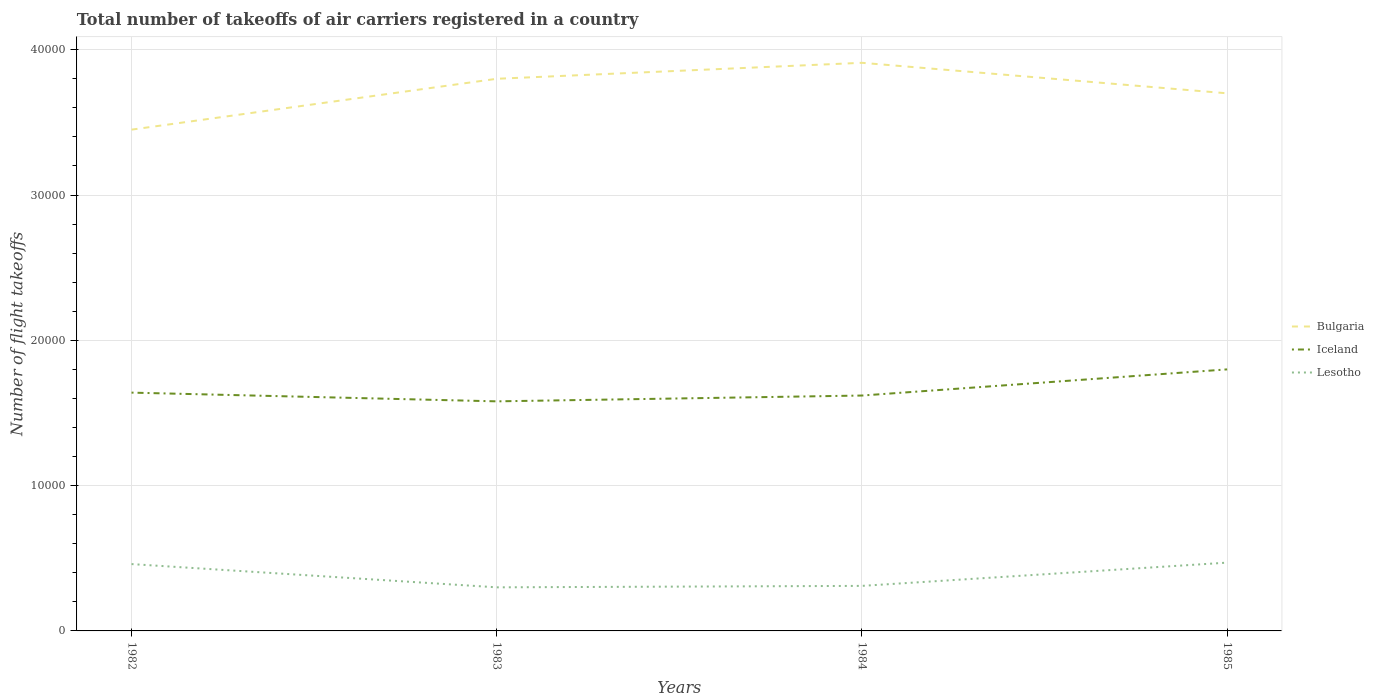Does the line corresponding to Lesotho intersect with the line corresponding to Bulgaria?
Your response must be concise. No. Across all years, what is the maximum total number of flight takeoffs in Bulgaria?
Your answer should be compact. 3.45e+04. In which year was the total number of flight takeoffs in Bulgaria maximum?
Make the answer very short. 1982. What is the total total number of flight takeoffs in Bulgaria in the graph?
Give a very brief answer. -3500. What is the difference between the highest and the second highest total number of flight takeoffs in Iceland?
Your answer should be very brief. 2200. Is the total number of flight takeoffs in Bulgaria strictly greater than the total number of flight takeoffs in Iceland over the years?
Provide a succinct answer. No. How many years are there in the graph?
Give a very brief answer. 4. What is the difference between two consecutive major ticks on the Y-axis?
Provide a short and direct response. 10000. Are the values on the major ticks of Y-axis written in scientific E-notation?
Your answer should be very brief. No. How many legend labels are there?
Provide a short and direct response. 3. What is the title of the graph?
Offer a terse response. Total number of takeoffs of air carriers registered in a country. Does "Montenegro" appear as one of the legend labels in the graph?
Your response must be concise. No. What is the label or title of the Y-axis?
Ensure brevity in your answer.  Number of flight takeoffs. What is the Number of flight takeoffs of Bulgaria in 1982?
Provide a succinct answer. 3.45e+04. What is the Number of flight takeoffs in Iceland in 1982?
Make the answer very short. 1.64e+04. What is the Number of flight takeoffs of Lesotho in 1982?
Provide a short and direct response. 4600. What is the Number of flight takeoffs of Bulgaria in 1983?
Your answer should be compact. 3.80e+04. What is the Number of flight takeoffs in Iceland in 1983?
Offer a very short reply. 1.58e+04. What is the Number of flight takeoffs in Lesotho in 1983?
Your answer should be very brief. 3000. What is the Number of flight takeoffs in Bulgaria in 1984?
Keep it short and to the point. 3.91e+04. What is the Number of flight takeoffs in Iceland in 1984?
Provide a succinct answer. 1.62e+04. What is the Number of flight takeoffs of Lesotho in 1984?
Keep it short and to the point. 3100. What is the Number of flight takeoffs in Bulgaria in 1985?
Give a very brief answer. 3.70e+04. What is the Number of flight takeoffs of Iceland in 1985?
Your response must be concise. 1.80e+04. What is the Number of flight takeoffs of Lesotho in 1985?
Make the answer very short. 4700. Across all years, what is the maximum Number of flight takeoffs of Bulgaria?
Offer a very short reply. 3.91e+04. Across all years, what is the maximum Number of flight takeoffs in Iceland?
Ensure brevity in your answer.  1.80e+04. Across all years, what is the maximum Number of flight takeoffs of Lesotho?
Offer a very short reply. 4700. Across all years, what is the minimum Number of flight takeoffs in Bulgaria?
Provide a short and direct response. 3.45e+04. Across all years, what is the minimum Number of flight takeoffs in Iceland?
Offer a terse response. 1.58e+04. Across all years, what is the minimum Number of flight takeoffs in Lesotho?
Offer a very short reply. 3000. What is the total Number of flight takeoffs in Bulgaria in the graph?
Your response must be concise. 1.49e+05. What is the total Number of flight takeoffs of Iceland in the graph?
Offer a very short reply. 6.64e+04. What is the total Number of flight takeoffs in Lesotho in the graph?
Provide a succinct answer. 1.54e+04. What is the difference between the Number of flight takeoffs in Bulgaria in 1982 and that in 1983?
Your answer should be compact. -3500. What is the difference between the Number of flight takeoffs in Iceland in 1982 and that in 1983?
Ensure brevity in your answer.  600. What is the difference between the Number of flight takeoffs in Lesotho in 1982 and that in 1983?
Your response must be concise. 1600. What is the difference between the Number of flight takeoffs of Bulgaria in 1982 and that in 1984?
Provide a succinct answer. -4600. What is the difference between the Number of flight takeoffs in Lesotho in 1982 and that in 1984?
Your answer should be compact. 1500. What is the difference between the Number of flight takeoffs in Bulgaria in 1982 and that in 1985?
Your response must be concise. -2500. What is the difference between the Number of flight takeoffs of Iceland in 1982 and that in 1985?
Your answer should be compact. -1600. What is the difference between the Number of flight takeoffs of Lesotho in 1982 and that in 1985?
Offer a very short reply. -100. What is the difference between the Number of flight takeoffs of Bulgaria in 1983 and that in 1984?
Offer a very short reply. -1100. What is the difference between the Number of flight takeoffs in Iceland in 1983 and that in 1984?
Your response must be concise. -400. What is the difference between the Number of flight takeoffs in Lesotho in 1983 and that in 1984?
Offer a terse response. -100. What is the difference between the Number of flight takeoffs in Bulgaria in 1983 and that in 1985?
Keep it short and to the point. 1000. What is the difference between the Number of flight takeoffs of Iceland in 1983 and that in 1985?
Offer a terse response. -2200. What is the difference between the Number of flight takeoffs of Lesotho in 1983 and that in 1985?
Provide a succinct answer. -1700. What is the difference between the Number of flight takeoffs in Bulgaria in 1984 and that in 1985?
Ensure brevity in your answer.  2100. What is the difference between the Number of flight takeoffs of Iceland in 1984 and that in 1985?
Offer a very short reply. -1800. What is the difference between the Number of flight takeoffs in Lesotho in 1984 and that in 1985?
Give a very brief answer. -1600. What is the difference between the Number of flight takeoffs in Bulgaria in 1982 and the Number of flight takeoffs in Iceland in 1983?
Your response must be concise. 1.87e+04. What is the difference between the Number of flight takeoffs in Bulgaria in 1982 and the Number of flight takeoffs in Lesotho in 1983?
Your answer should be compact. 3.15e+04. What is the difference between the Number of flight takeoffs of Iceland in 1982 and the Number of flight takeoffs of Lesotho in 1983?
Offer a terse response. 1.34e+04. What is the difference between the Number of flight takeoffs in Bulgaria in 1982 and the Number of flight takeoffs in Iceland in 1984?
Ensure brevity in your answer.  1.83e+04. What is the difference between the Number of flight takeoffs in Bulgaria in 1982 and the Number of flight takeoffs in Lesotho in 1984?
Make the answer very short. 3.14e+04. What is the difference between the Number of flight takeoffs in Iceland in 1982 and the Number of flight takeoffs in Lesotho in 1984?
Give a very brief answer. 1.33e+04. What is the difference between the Number of flight takeoffs of Bulgaria in 1982 and the Number of flight takeoffs of Iceland in 1985?
Provide a short and direct response. 1.65e+04. What is the difference between the Number of flight takeoffs in Bulgaria in 1982 and the Number of flight takeoffs in Lesotho in 1985?
Offer a very short reply. 2.98e+04. What is the difference between the Number of flight takeoffs of Iceland in 1982 and the Number of flight takeoffs of Lesotho in 1985?
Your answer should be compact. 1.17e+04. What is the difference between the Number of flight takeoffs of Bulgaria in 1983 and the Number of flight takeoffs of Iceland in 1984?
Make the answer very short. 2.18e+04. What is the difference between the Number of flight takeoffs of Bulgaria in 1983 and the Number of flight takeoffs of Lesotho in 1984?
Make the answer very short. 3.49e+04. What is the difference between the Number of flight takeoffs of Iceland in 1983 and the Number of flight takeoffs of Lesotho in 1984?
Your response must be concise. 1.27e+04. What is the difference between the Number of flight takeoffs in Bulgaria in 1983 and the Number of flight takeoffs in Lesotho in 1985?
Provide a succinct answer. 3.33e+04. What is the difference between the Number of flight takeoffs of Iceland in 1983 and the Number of flight takeoffs of Lesotho in 1985?
Offer a terse response. 1.11e+04. What is the difference between the Number of flight takeoffs of Bulgaria in 1984 and the Number of flight takeoffs of Iceland in 1985?
Make the answer very short. 2.11e+04. What is the difference between the Number of flight takeoffs of Bulgaria in 1984 and the Number of flight takeoffs of Lesotho in 1985?
Ensure brevity in your answer.  3.44e+04. What is the difference between the Number of flight takeoffs in Iceland in 1984 and the Number of flight takeoffs in Lesotho in 1985?
Your answer should be very brief. 1.15e+04. What is the average Number of flight takeoffs of Bulgaria per year?
Provide a short and direct response. 3.72e+04. What is the average Number of flight takeoffs in Iceland per year?
Your answer should be very brief. 1.66e+04. What is the average Number of flight takeoffs of Lesotho per year?
Make the answer very short. 3850. In the year 1982, what is the difference between the Number of flight takeoffs in Bulgaria and Number of flight takeoffs in Iceland?
Provide a short and direct response. 1.81e+04. In the year 1982, what is the difference between the Number of flight takeoffs of Bulgaria and Number of flight takeoffs of Lesotho?
Offer a terse response. 2.99e+04. In the year 1982, what is the difference between the Number of flight takeoffs in Iceland and Number of flight takeoffs in Lesotho?
Your answer should be compact. 1.18e+04. In the year 1983, what is the difference between the Number of flight takeoffs in Bulgaria and Number of flight takeoffs in Iceland?
Provide a succinct answer. 2.22e+04. In the year 1983, what is the difference between the Number of flight takeoffs of Bulgaria and Number of flight takeoffs of Lesotho?
Give a very brief answer. 3.50e+04. In the year 1983, what is the difference between the Number of flight takeoffs of Iceland and Number of flight takeoffs of Lesotho?
Keep it short and to the point. 1.28e+04. In the year 1984, what is the difference between the Number of flight takeoffs of Bulgaria and Number of flight takeoffs of Iceland?
Your response must be concise. 2.29e+04. In the year 1984, what is the difference between the Number of flight takeoffs in Bulgaria and Number of flight takeoffs in Lesotho?
Your response must be concise. 3.60e+04. In the year 1984, what is the difference between the Number of flight takeoffs in Iceland and Number of flight takeoffs in Lesotho?
Provide a succinct answer. 1.31e+04. In the year 1985, what is the difference between the Number of flight takeoffs of Bulgaria and Number of flight takeoffs of Iceland?
Your answer should be very brief. 1.90e+04. In the year 1985, what is the difference between the Number of flight takeoffs of Bulgaria and Number of flight takeoffs of Lesotho?
Your response must be concise. 3.23e+04. In the year 1985, what is the difference between the Number of flight takeoffs in Iceland and Number of flight takeoffs in Lesotho?
Your response must be concise. 1.33e+04. What is the ratio of the Number of flight takeoffs in Bulgaria in 1982 to that in 1983?
Ensure brevity in your answer.  0.91. What is the ratio of the Number of flight takeoffs in Iceland in 1982 to that in 1983?
Your answer should be compact. 1.04. What is the ratio of the Number of flight takeoffs in Lesotho in 1982 to that in 1983?
Make the answer very short. 1.53. What is the ratio of the Number of flight takeoffs in Bulgaria in 1982 to that in 1984?
Your response must be concise. 0.88. What is the ratio of the Number of flight takeoffs of Iceland in 1982 to that in 1984?
Your answer should be compact. 1.01. What is the ratio of the Number of flight takeoffs in Lesotho in 1982 to that in 1984?
Your answer should be very brief. 1.48. What is the ratio of the Number of flight takeoffs in Bulgaria in 1982 to that in 1985?
Give a very brief answer. 0.93. What is the ratio of the Number of flight takeoffs in Iceland in 1982 to that in 1985?
Your answer should be compact. 0.91. What is the ratio of the Number of flight takeoffs of Lesotho in 1982 to that in 1985?
Make the answer very short. 0.98. What is the ratio of the Number of flight takeoffs of Bulgaria in 1983 to that in 1984?
Your answer should be very brief. 0.97. What is the ratio of the Number of flight takeoffs of Iceland in 1983 to that in 1984?
Keep it short and to the point. 0.98. What is the ratio of the Number of flight takeoffs of Lesotho in 1983 to that in 1984?
Your answer should be very brief. 0.97. What is the ratio of the Number of flight takeoffs in Iceland in 1983 to that in 1985?
Ensure brevity in your answer.  0.88. What is the ratio of the Number of flight takeoffs of Lesotho in 1983 to that in 1985?
Keep it short and to the point. 0.64. What is the ratio of the Number of flight takeoffs in Bulgaria in 1984 to that in 1985?
Make the answer very short. 1.06. What is the ratio of the Number of flight takeoffs in Lesotho in 1984 to that in 1985?
Provide a succinct answer. 0.66. What is the difference between the highest and the second highest Number of flight takeoffs in Bulgaria?
Your answer should be very brief. 1100. What is the difference between the highest and the second highest Number of flight takeoffs of Iceland?
Provide a succinct answer. 1600. What is the difference between the highest and the second highest Number of flight takeoffs in Lesotho?
Make the answer very short. 100. What is the difference between the highest and the lowest Number of flight takeoffs in Bulgaria?
Make the answer very short. 4600. What is the difference between the highest and the lowest Number of flight takeoffs of Iceland?
Provide a short and direct response. 2200. What is the difference between the highest and the lowest Number of flight takeoffs in Lesotho?
Give a very brief answer. 1700. 